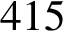Convert formula to latex. <formula><loc_0><loc_0><loc_500><loc_500>4 1 5</formula> 